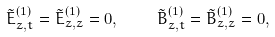<formula> <loc_0><loc_0><loc_500><loc_500>\tilde { E } ^ { ( 1 ) } _ { z , t } = \tilde { E } ^ { ( 1 ) } _ { z , z } = 0 , \quad \tilde { B } ^ { ( 1 ) } _ { z , t } = \tilde { B } ^ { ( 1 ) } _ { z , z } = 0 ,</formula> 